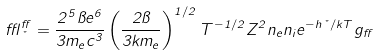<formula> <loc_0><loc_0><loc_500><loc_500>\epsilon ^ { f f } _ { \nu } = \frac { 2 ^ { 5 } \pi e ^ { 6 } } { 3 m _ { e } c ^ { 3 } } \left ( \frac { 2 \pi } { 3 k m _ { e } } \right ) ^ { 1 / 2 } T ^ { - 1 / 2 } Z ^ { 2 } n _ { e } n _ { i } e ^ { - h \nu / k T } g _ { f f }</formula> 